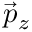<formula> <loc_0><loc_0><loc_500><loc_500>\vec { p } _ { z }</formula> 